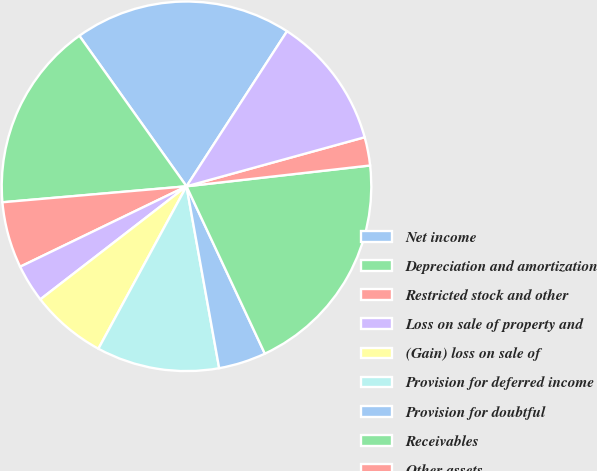Convert chart to OTSL. <chart><loc_0><loc_0><loc_500><loc_500><pie_chart><fcel>Net income<fcel>Depreciation and amortization<fcel>Restricted stock and other<fcel>Loss on sale of property and<fcel>(Gain) loss on sale of<fcel>Provision for deferred income<fcel>Provision for doubtful<fcel>Receivables<fcel>Other assets<fcel>Medical and other expenses<nl><fcel>19.0%<fcel>16.53%<fcel>5.79%<fcel>3.31%<fcel>6.61%<fcel>10.74%<fcel>4.14%<fcel>19.83%<fcel>2.48%<fcel>11.57%<nl></chart> 